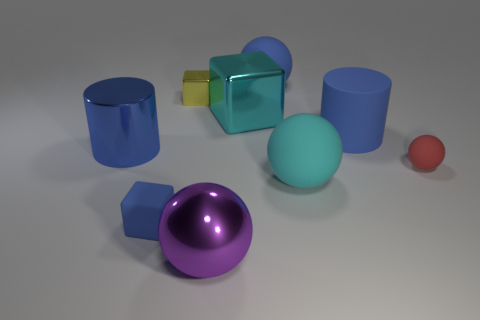The tiny object that is on the right side of the large thing that is in front of the blue cube is what shape?
Provide a succinct answer. Sphere. What number of large balls are in front of the rubber thing that is left of the large purple metal thing?
Make the answer very short. 1. There is a object that is both behind the big block and right of the yellow metallic object; what material is it made of?
Keep it short and to the point. Rubber. What shape is the cyan metallic thing that is the same size as the matte cylinder?
Offer a very short reply. Cube. What is the color of the matte thing that is behind the cube behind the cyan thing to the left of the large cyan matte thing?
Give a very brief answer. Blue. How many objects are large metal objects that are in front of the large blue metal cylinder or big brown shiny things?
Offer a very short reply. 1. There is another yellow cube that is the same size as the rubber block; what material is it?
Your answer should be very brief. Metal. What is the material of the large cyan object that is left of the large matte thing in front of the large blue cylinder on the left side of the purple metallic ball?
Your answer should be compact. Metal. What is the color of the tiny rubber cube?
Make the answer very short. Blue. How many large objects are yellow metal objects or gray cubes?
Your answer should be compact. 0. 